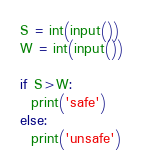<code> <loc_0><loc_0><loc_500><loc_500><_Python_>S = int(input())
W = int(input())

if S>W:
  print('safe')
else:
  print('unsafe')
</code> 